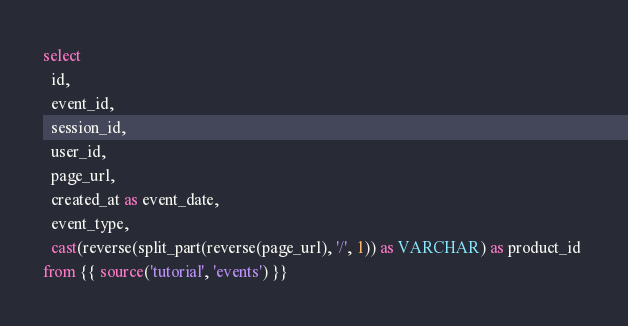Convert code to text. <code><loc_0><loc_0><loc_500><loc_500><_SQL_>select
  id,
  event_id,
  session_id,
  user_id,
  page_url,
  created_at as event_date,
  event_type,
  cast(reverse(split_part(reverse(page_url), '/', 1)) as VARCHAR) as product_id 
from {{ source('tutorial', 'events') }}</code> 